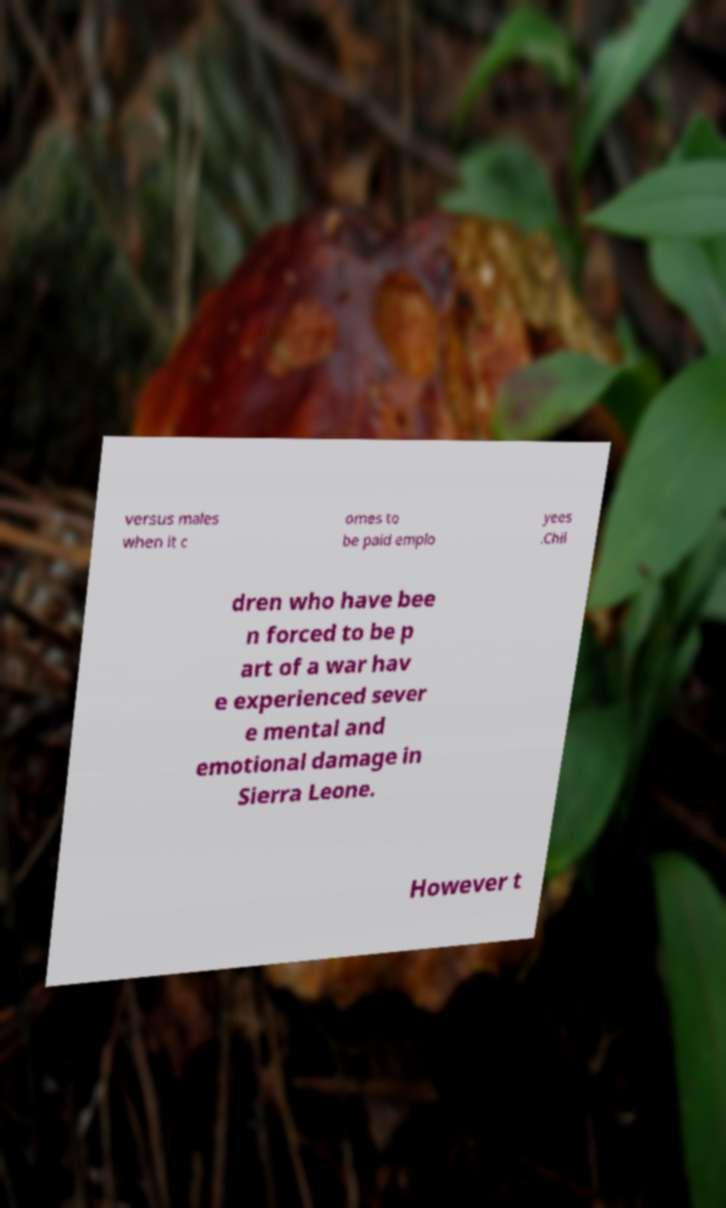Can you read and provide the text displayed in the image?This photo seems to have some interesting text. Can you extract and type it out for me? versus males when it c omes to be paid emplo yees .Chil dren who have bee n forced to be p art of a war hav e experienced sever e mental and emotional damage in Sierra Leone. However t 